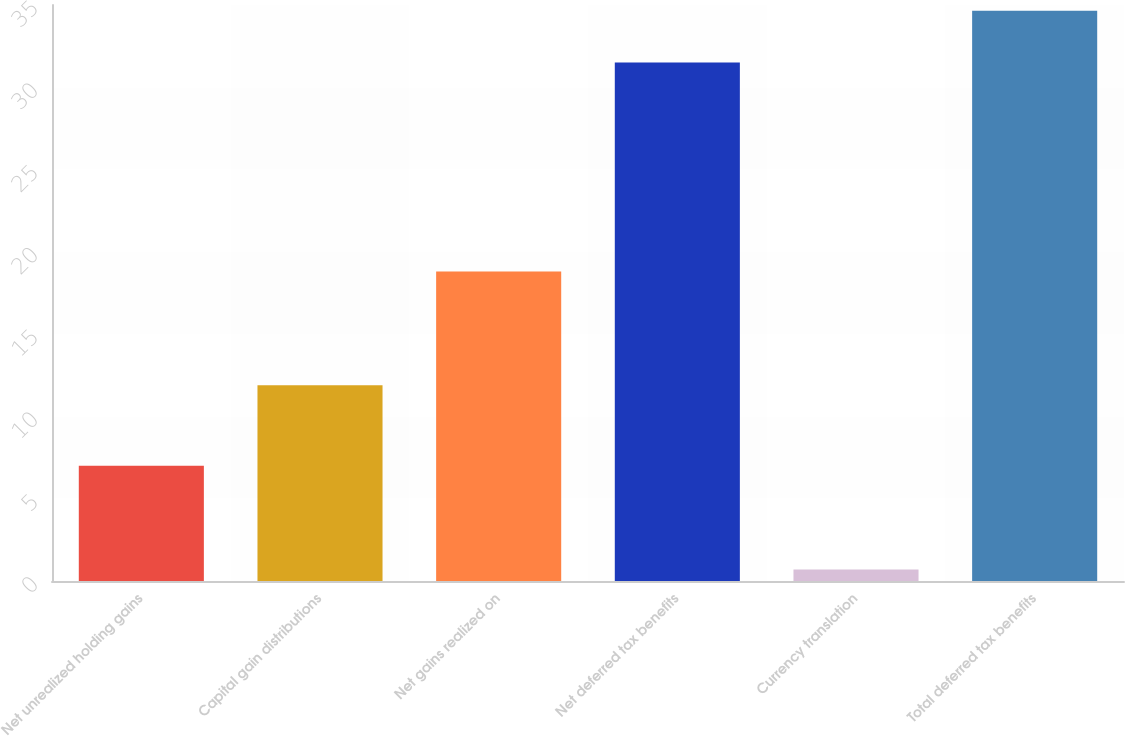Convert chart to OTSL. <chart><loc_0><loc_0><loc_500><loc_500><bar_chart><fcel>Net unrealized holding gains<fcel>Capital gain distributions<fcel>Net gains realized on<fcel>Net deferred tax benefits<fcel>Currency translation<fcel>Total deferred tax benefits<nl><fcel>7<fcel>11.9<fcel>18.8<fcel>31.5<fcel>0.7<fcel>34.65<nl></chart> 